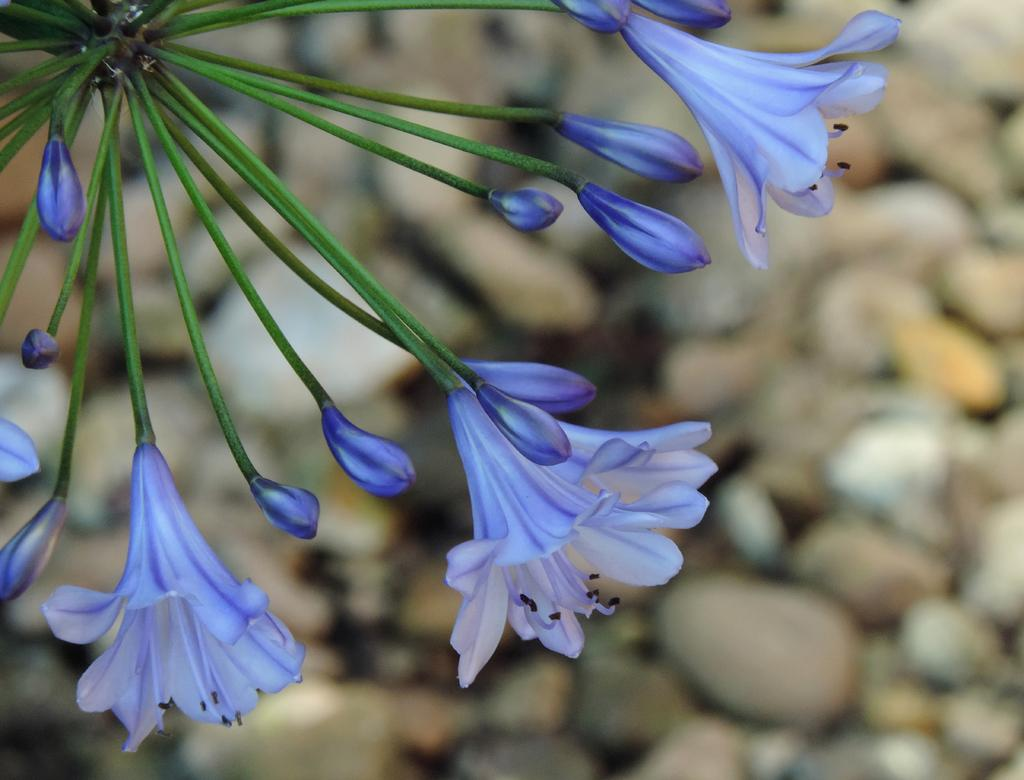What type of plants can be seen in the image? There are flowers in the image. Are there any flower buds visible in the image? Yes, there are flower buds in the image. What can be seen in the background of the image? There are stones visible in the background of the image. How many babies are holding the flowers in the image? There are no babies present in the image; it features flowers and flower buds. What type of leaf can be seen on the flowers in the image? There is no specific leaf mentioned or visible in the image; it only shows flowers and flower buds. 